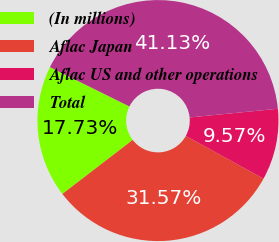Convert chart to OTSL. <chart><loc_0><loc_0><loc_500><loc_500><pie_chart><fcel>(In millions)<fcel>Aflac Japan<fcel>Aflac US and other operations<fcel>Total<nl><fcel>17.73%<fcel>31.57%<fcel>9.57%<fcel>41.13%<nl></chart> 